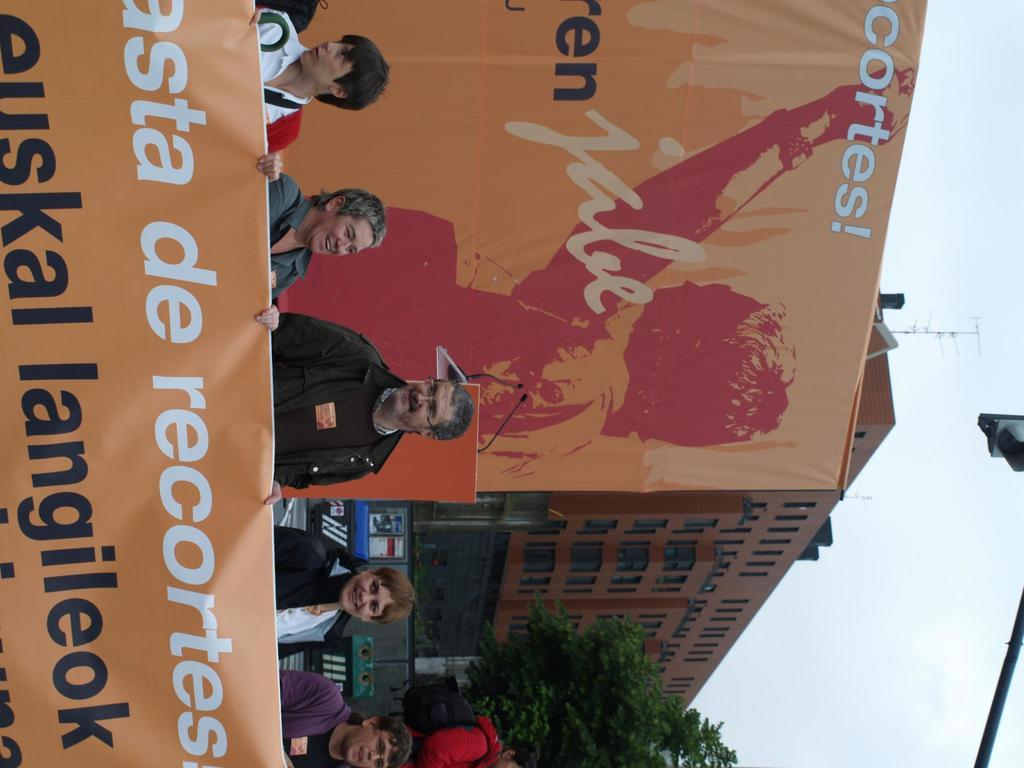What are the people in the image doing? The people in the image are holding a banner. Can you describe the banner in the image? There is a banner in the background of the image. What can be seen in the background of the image? There is a building and trees in the background of the image. What is the body condition of the person holding the banner in the image? There is no information about the body condition of the person holding the banner in the image. 